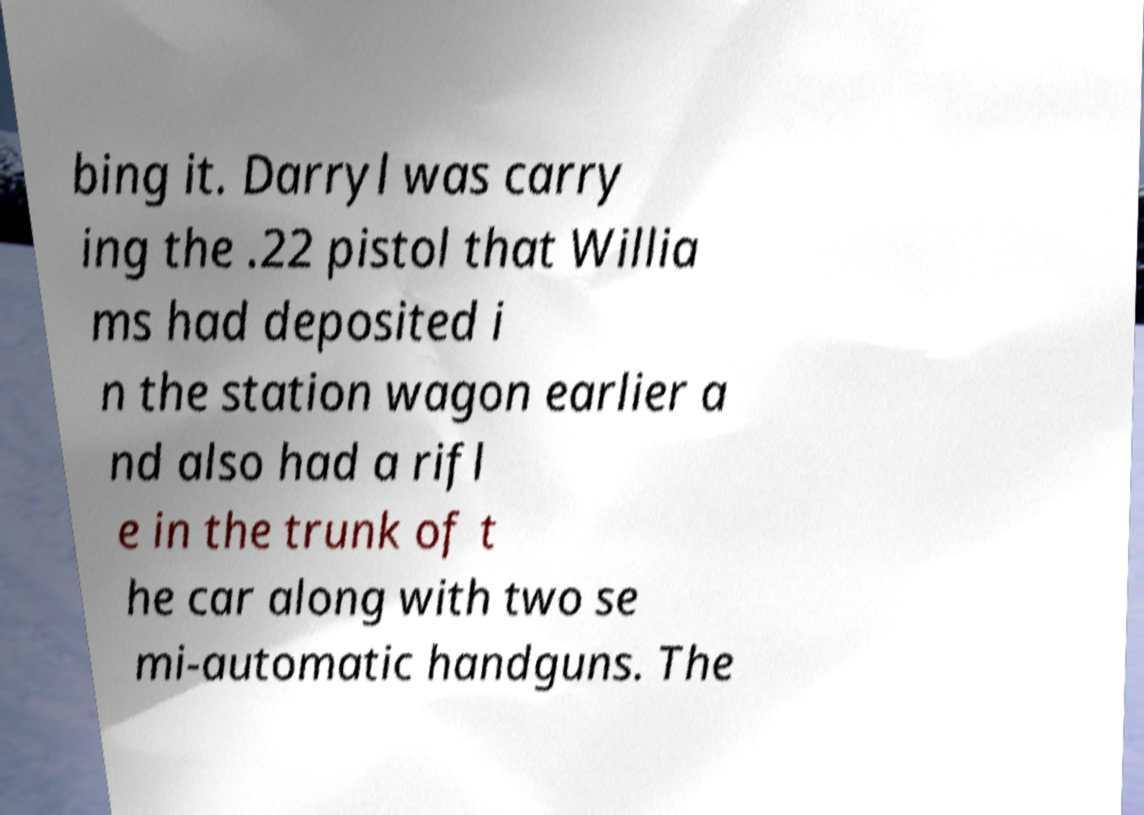I need the written content from this picture converted into text. Can you do that? bing it. Darryl was carry ing the .22 pistol that Willia ms had deposited i n the station wagon earlier a nd also had a rifl e in the trunk of t he car along with two se mi-automatic handguns. The 